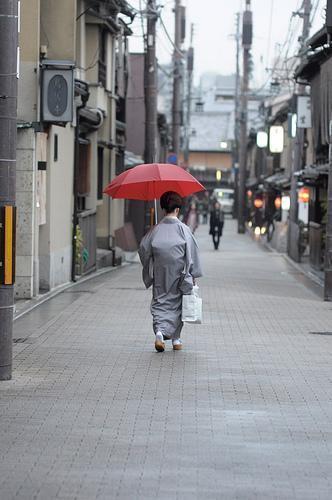How many of the trains are green on front?
Give a very brief answer. 0. 